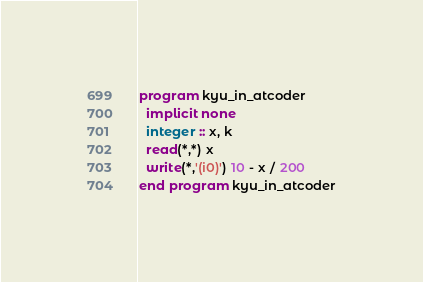<code> <loc_0><loc_0><loc_500><loc_500><_FORTRAN_>program kyu_in_atcoder
  implicit none
  integer :: x, k
  read(*,*) x
  write(*,'(i0)') 10 - x / 200
end program kyu_in_atcoder</code> 